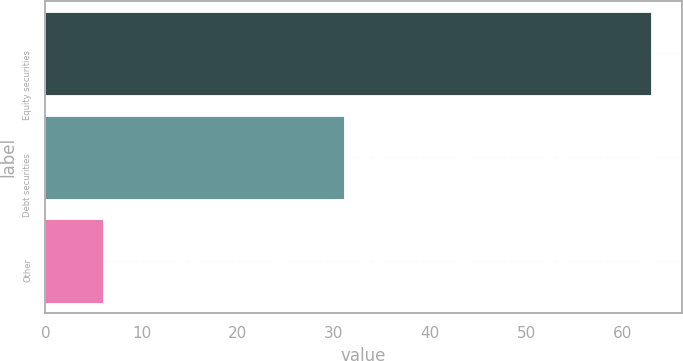<chart> <loc_0><loc_0><loc_500><loc_500><bar_chart><fcel>Equity securities<fcel>Debt securities<fcel>Other<nl><fcel>63<fcel>31<fcel>6<nl></chart> 